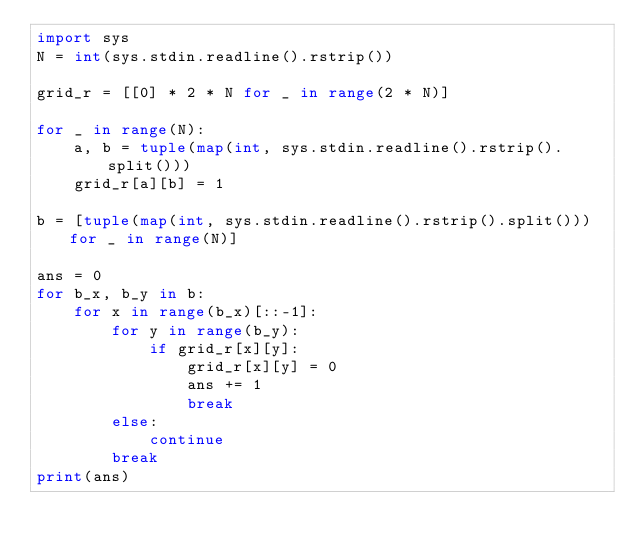Convert code to text. <code><loc_0><loc_0><loc_500><loc_500><_Python_>import sys
N = int(sys.stdin.readline().rstrip())

grid_r = [[0] * 2 * N for _ in range(2 * N)]

for _ in range(N):
    a, b = tuple(map(int, sys.stdin.readline().rstrip().split()))
    grid_r[a][b] = 1

b = [tuple(map(int, sys.stdin.readline().rstrip().split())) for _ in range(N)]

ans = 0
for b_x, b_y in b:
    for x in range(b_x)[::-1]:
        for y in range(b_y):
            if grid_r[x][y]:
                grid_r[x][y] = 0
                ans += 1
                break
        else:
            continue
        break
print(ans)</code> 